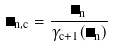<formula> <loc_0><loc_0><loc_500><loc_500>\Gamma _ { n , c } = \frac { \Gamma _ { n } } { \gamma _ { c + 1 } ( \Gamma _ { n } ) }</formula> 